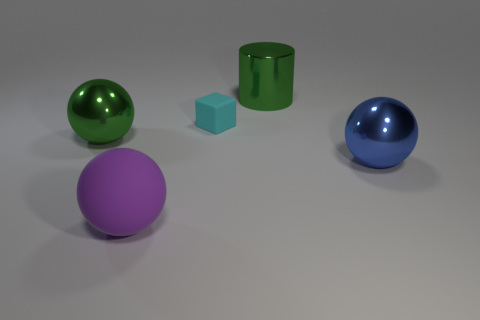There is a shiny object left of the tiny cyan object; does it have the same color as the cylinder?
Offer a very short reply. Yes. What size is the green metal thing that is the same shape as the large rubber thing?
Give a very brief answer. Large. There is a green object on the right side of the purple rubber object; does it have the same shape as the blue metallic object?
Make the answer very short. No. What shape is the green thing that is right of the large shiny object that is on the left side of the cylinder?
Offer a very short reply. Cylinder. Is there any other thing that has the same shape as the blue metal thing?
Ensure brevity in your answer.  Yes. There is another big matte object that is the same shape as the blue thing; what is its color?
Provide a succinct answer. Purple. Does the small rubber thing have the same color as the large shiny object left of the matte ball?
Your answer should be compact. No. What is the shape of the metallic thing that is to the right of the purple thing and in front of the small cyan thing?
Provide a succinct answer. Sphere. Is the number of gray blocks less than the number of things?
Give a very brief answer. Yes. Are any big matte balls visible?
Offer a very short reply. Yes. 